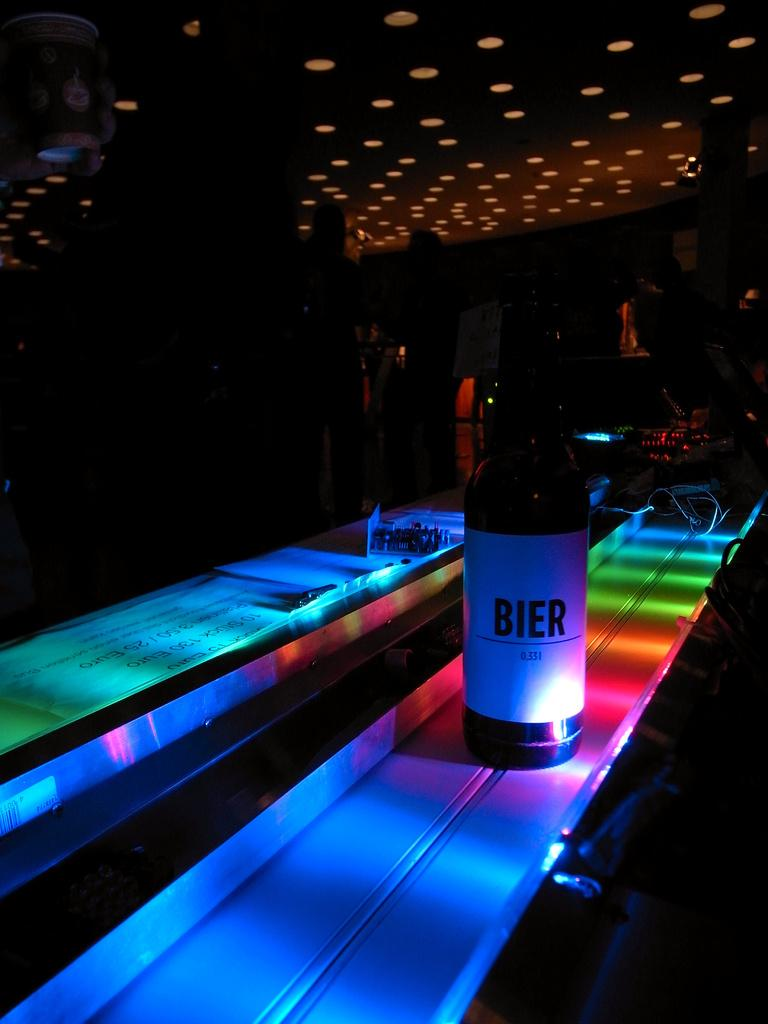<image>
Present a compact description of the photo's key features. Dark bottle of BIER inside of a dark club room. 